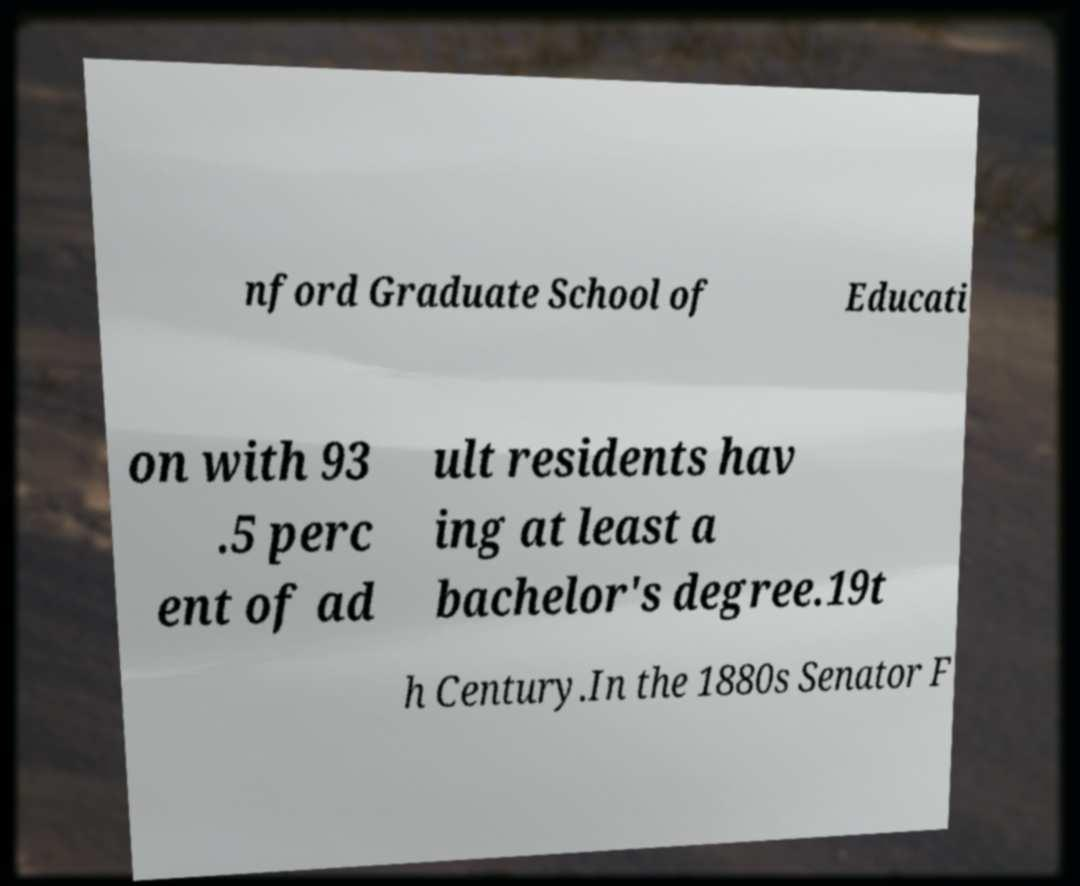Please identify and transcribe the text found in this image. nford Graduate School of Educati on with 93 .5 perc ent of ad ult residents hav ing at least a bachelor's degree.19t h Century.In the 1880s Senator F 